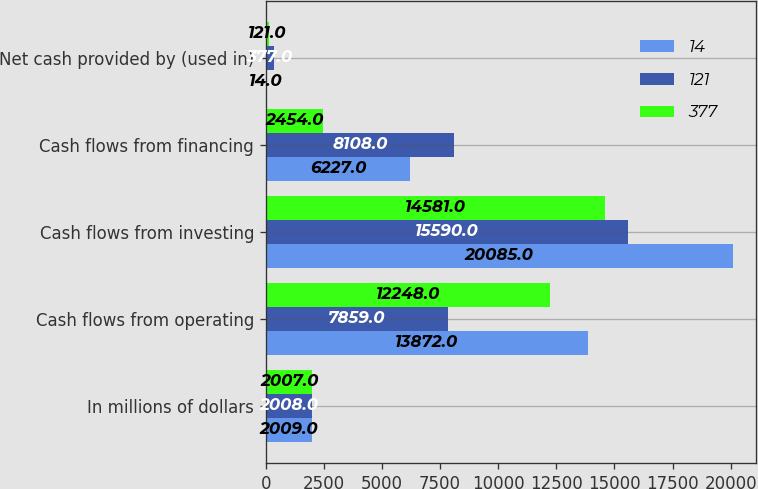<chart> <loc_0><loc_0><loc_500><loc_500><stacked_bar_chart><ecel><fcel>In millions of dollars<fcel>Cash flows from operating<fcel>Cash flows from investing<fcel>Cash flows from financing<fcel>Net cash provided by (used in)<nl><fcel>14<fcel>2009<fcel>13872<fcel>20085<fcel>6227<fcel>14<nl><fcel>121<fcel>2008<fcel>7859<fcel>15590<fcel>8108<fcel>377<nl><fcel>377<fcel>2007<fcel>12248<fcel>14581<fcel>2454<fcel>121<nl></chart> 